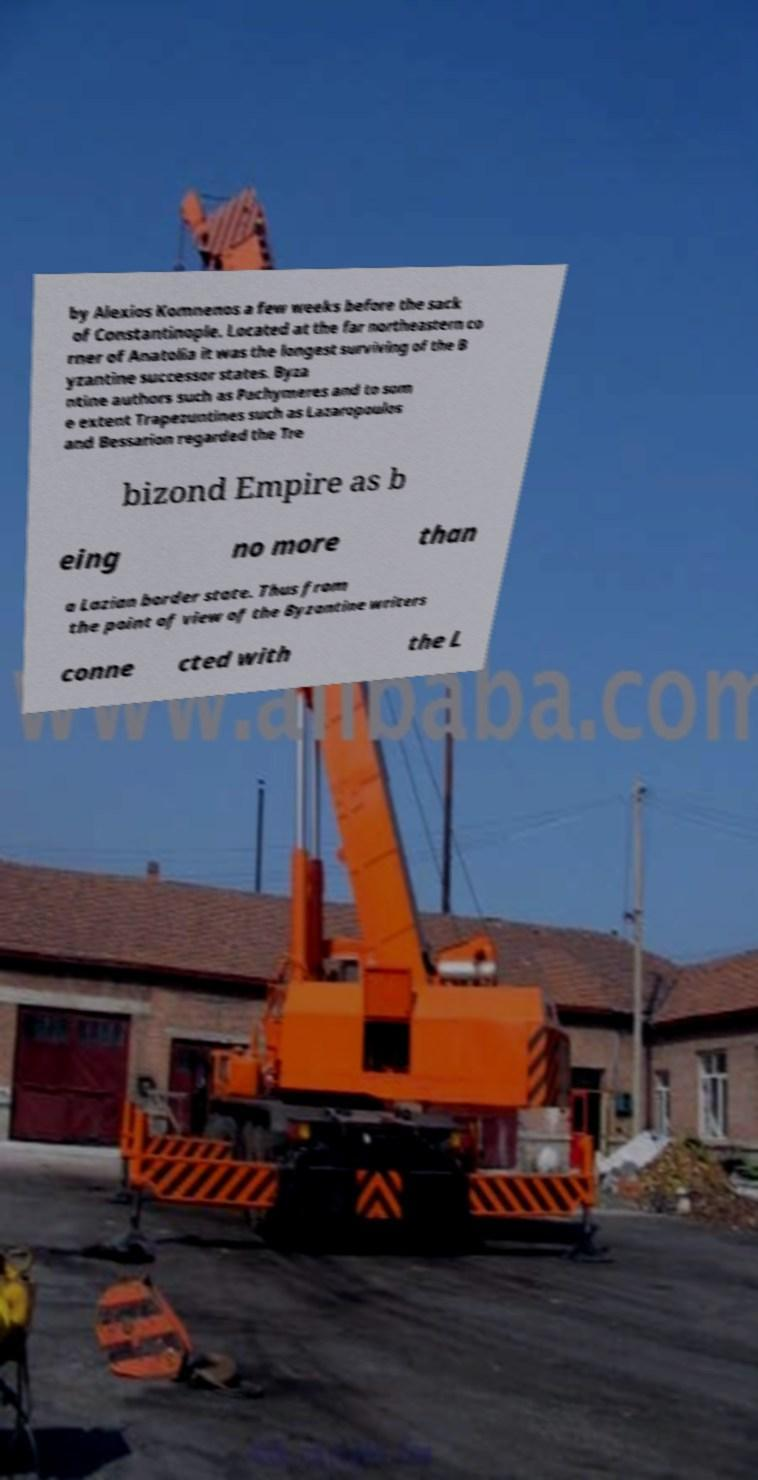What messages or text are displayed in this image? I need them in a readable, typed format. by Alexios Komnenos a few weeks before the sack of Constantinople. Located at the far northeastern co rner of Anatolia it was the longest surviving of the B yzantine successor states. Byza ntine authors such as Pachymeres and to som e extent Trapezuntines such as Lazaropoulos and Bessarion regarded the Tre bizond Empire as b eing no more than a Lazian border state. Thus from the point of view of the Byzantine writers conne cted with the L 